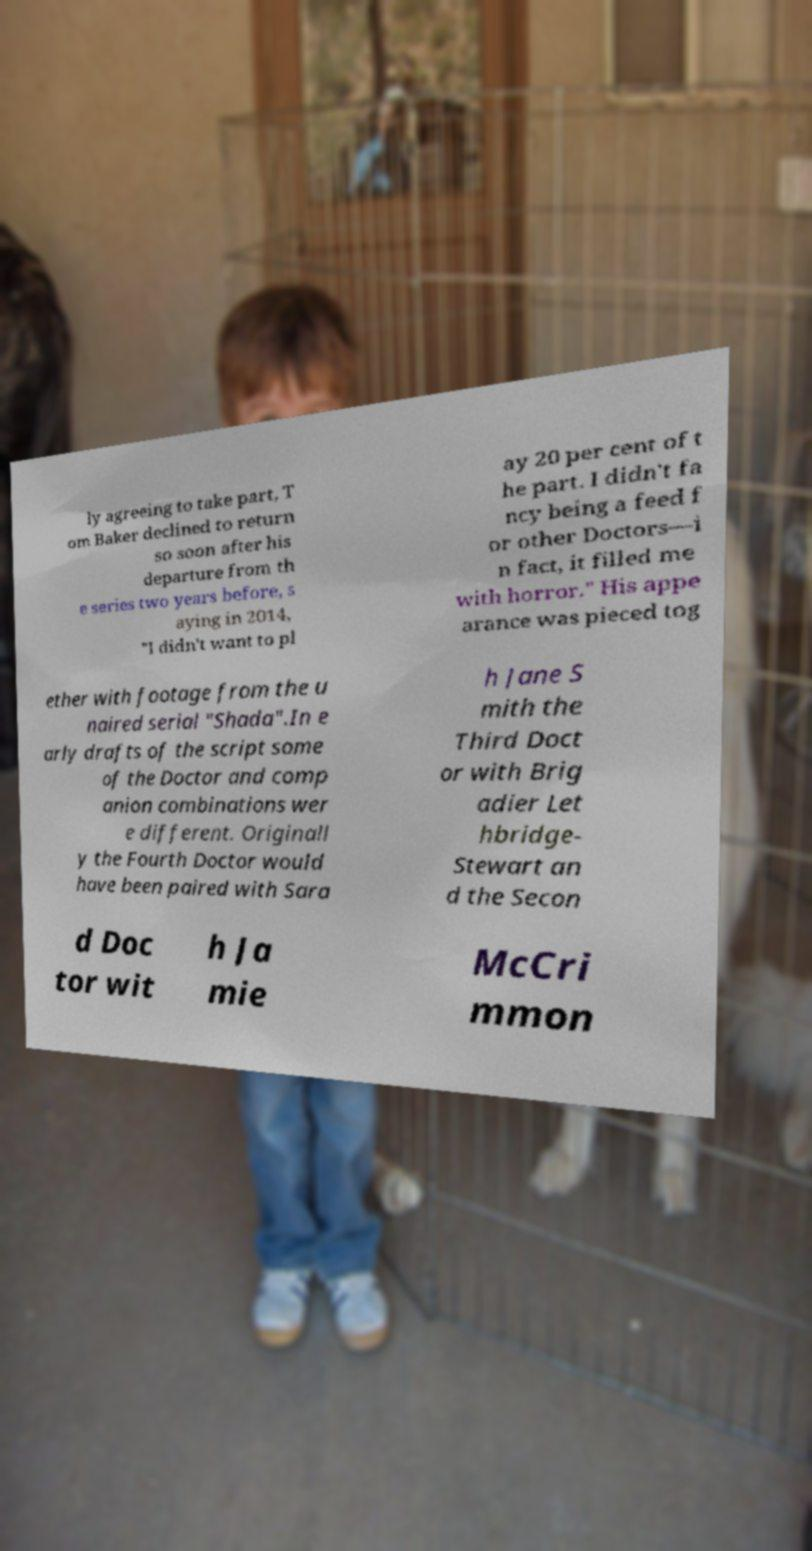Please identify and transcribe the text found in this image. ly agreeing to take part, T om Baker declined to return so soon after his departure from th e series two years before, s aying in 2014, "I didn't want to pl ay 20 per cent of t he part. I didn't fa ncy being a feed f or other Doctors—i n fact, it filled me with horror." His appe arance was pieced tog ether with footage from the u naired serial "Shada".In e arly drafts of the script some of the Doctor and comp anion combinations wer e different. Originall y the Fourth Doctor would have been paired with Sara h Jane S mith the Third Doct or with Brig adier Let hbridge- Stewart an d the Secon d Doc tor wit h Ja mie McCri mmon 